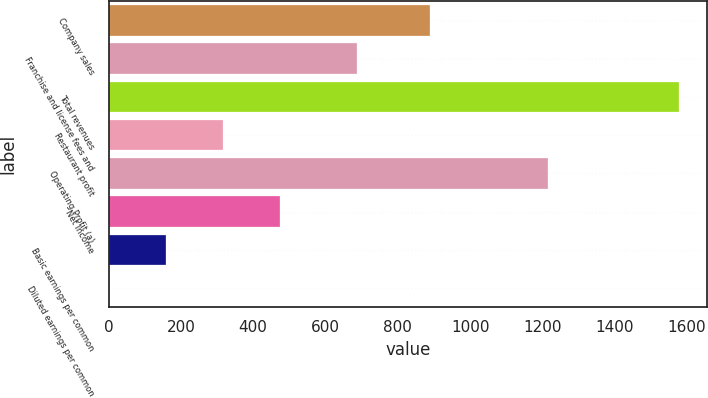<chart> <loc_0><loc_0><loc_500><loc_500><bar_chart><fcel>Company sales<fcel>Franchise and license fees and<fcel>Total revenues<fcel>Restaurant profit<fcel>Operating Profit (a)<fcel>Net Income<fcel>Basic earnings per common<fcel>Diluted earnings per common<nl><fcel>890<fcel>687<fcel>1577<fcel>316.4<fcel>1215<fcel>473.97<fcel>158.83<fcel>1.26<nl></chart> 